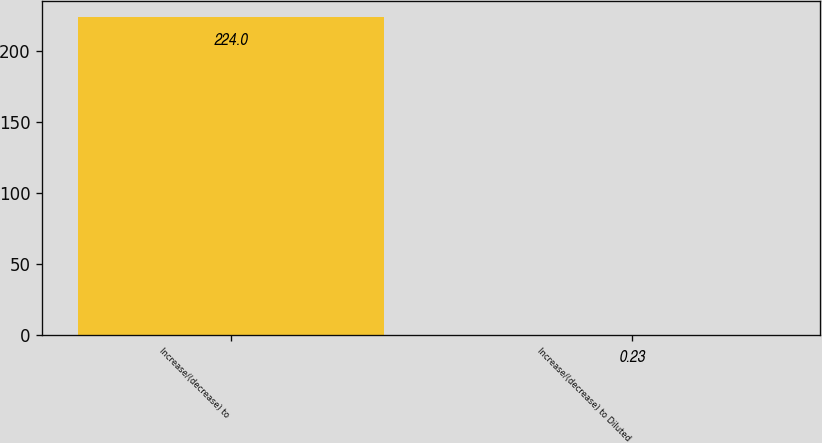<chart> <loc_0><loc_0><loc_500><loc_500><bar_chart><fcel>Increase/(decrease) to<fcel>Increase/(decrease) to Diluted<nl><fcel>224<fcel>0.23<nl></chart> 